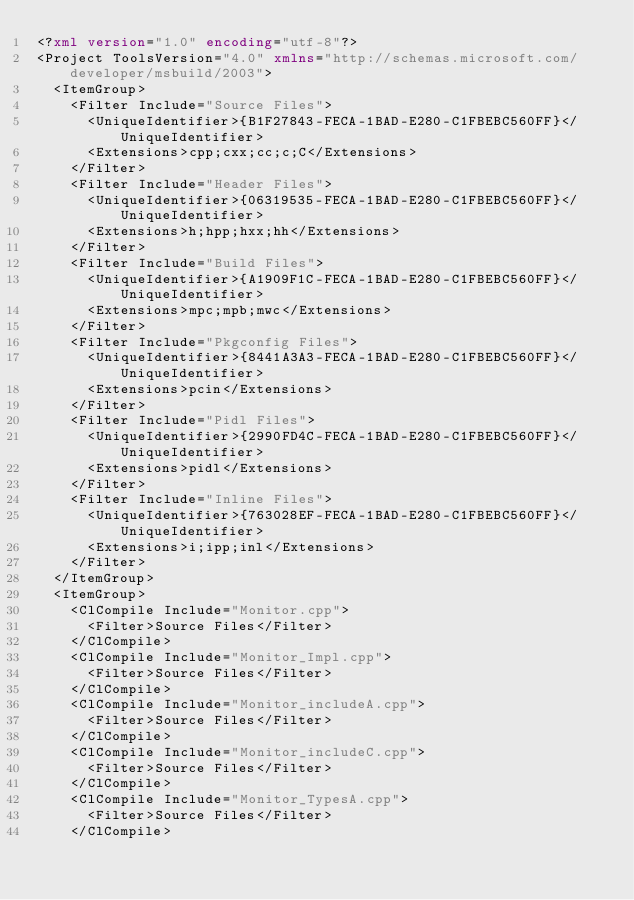Convert code to text. <code><loc_0><loc_0><loc_500><loc_500><_XML_><?xml version="1.0" encoding="utf-8"?>
<Project ToolsVersion="4.0" xmlns="http://schemas.microsoft.com/developer/msbuild/2003">
  <ItemGroup>
    <Filter Include="Source Files">
      <UniqueIdentifier>{B1F27843-FECA-1BAD-E280-C1FBEBC560FF}</UniqueIdentifier>
      <Extensions>cpp;cxx;cc;c;C</Extensions>
    </Filter>
    <Filter Include="Header Files">
      <UniqueIdentifier>{06319535-FECA-1BAD-E280-C1FBEBC560FF}</UniqueIdentifier>
      <Extensions>h;hpp;hxx;hh</Extensions>
    </Filter>
    <Filter Include="Build Files">
      <UniqueIdentifier>{A1909F1C-FECA-1BAD-E280-C1FBEBC560FF}</UniqueIdentifier>
      <Extensions>mpc;mpb;mwc</Extensions>
    </Filter>
    <Filter Include="Pkgconfig Files">
      <UniqueIdentifier>{8441A3A3-FECA-1BAD-E280-C1FBEBC560FF}</UniqueIdentifier>
      <Extensions>pcin</Extensions>
    </Filter>
    <Filter Include="Pidl Files">
      <UniqueIdentifier>{2990FD4C-FECA-1BAD-E280-C1FBEBC560FF}</UniqueIdentifier>
      <Extensions>pidl</Extensions>
    </Filter>
    <Filter Include="Inline Files">
      <UniqueIdentifier>{763028EF-FECA-1BAD-E280-C1FBEBC560FF}</UniqueIdentifier>
      <Extensions>i;ipp;inl</Extensions>
    </Filter>
  </ItemGroup>
  <ItemGroup>
    <ClCompile Include="Monitor.cpp">
      <Filter>Source Files</Filter>
    </ClCompile>
    <ClCompile Include="Monitor_Impl.cpp">
      <Filter>Source Files</Filter>
    </ClCompile>
    <ClCompile Include="Monitor_includeA.cpp">
      <Filter>Source Files</Filter>
    </ClCompile>
    <ClCompile Include="Monitor_includeC.cpp">
      <Filter>Source Files</Filter>
    </ClCompile>
    <ClCompile Include="Monitor_TypesA.cpp">
      <Filter>Source Files</Filter>
    </ClCompile></code> 